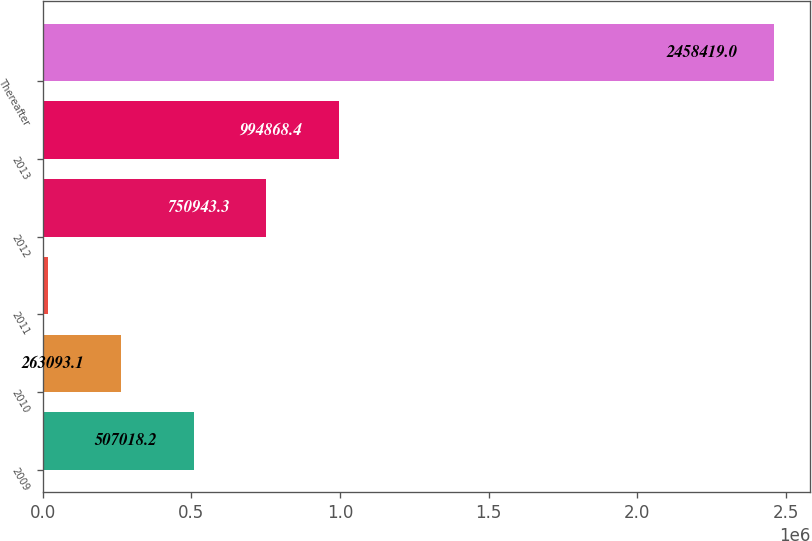<chart> <loc_0><loc_0><loc_500><loc_500><bar_chart><fcel>2009<fcel>2010<fcel>2011<fcel>2012<fcel>2013<fcel>Thereafter<nl><fcel>507018<fcel>263093<fcel>19168<fcel>750943<fcel>994868<fcel>2.45842e+06<nl></chart> 